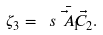<formula> <loc_0><loc_0><loc_500><loc_500>\zeta _ { 3 } = \ s { \bar { \vec { A } _ { 1 } } } { \vec { C } _ { 2 } } .</formula> 